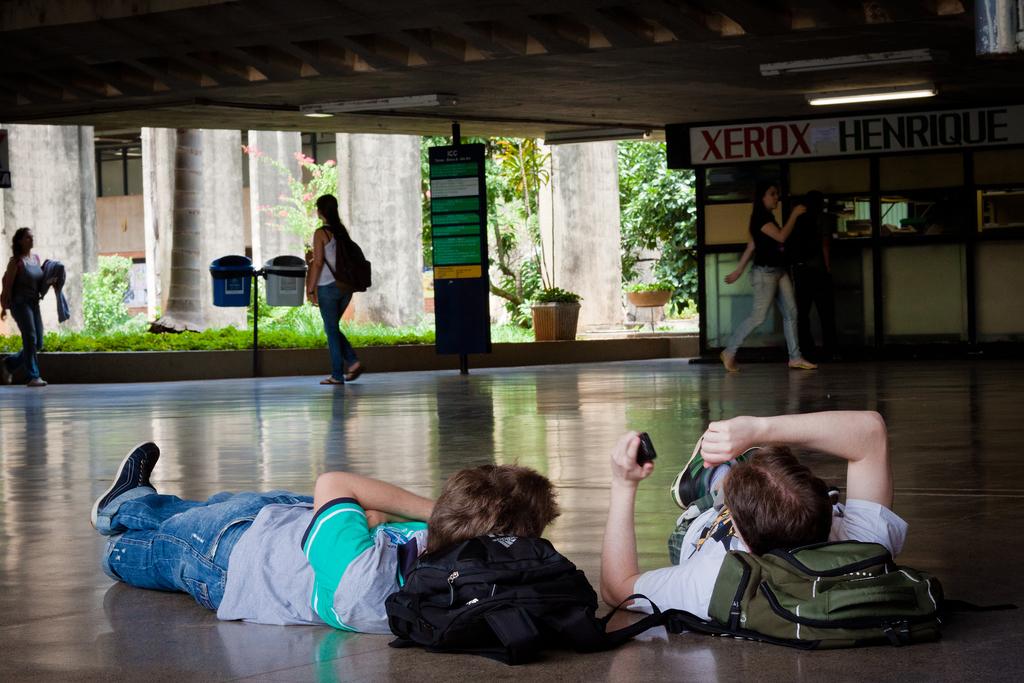Brand name of printers in the the top of the picture?
Offer a terse response. Xerox. 